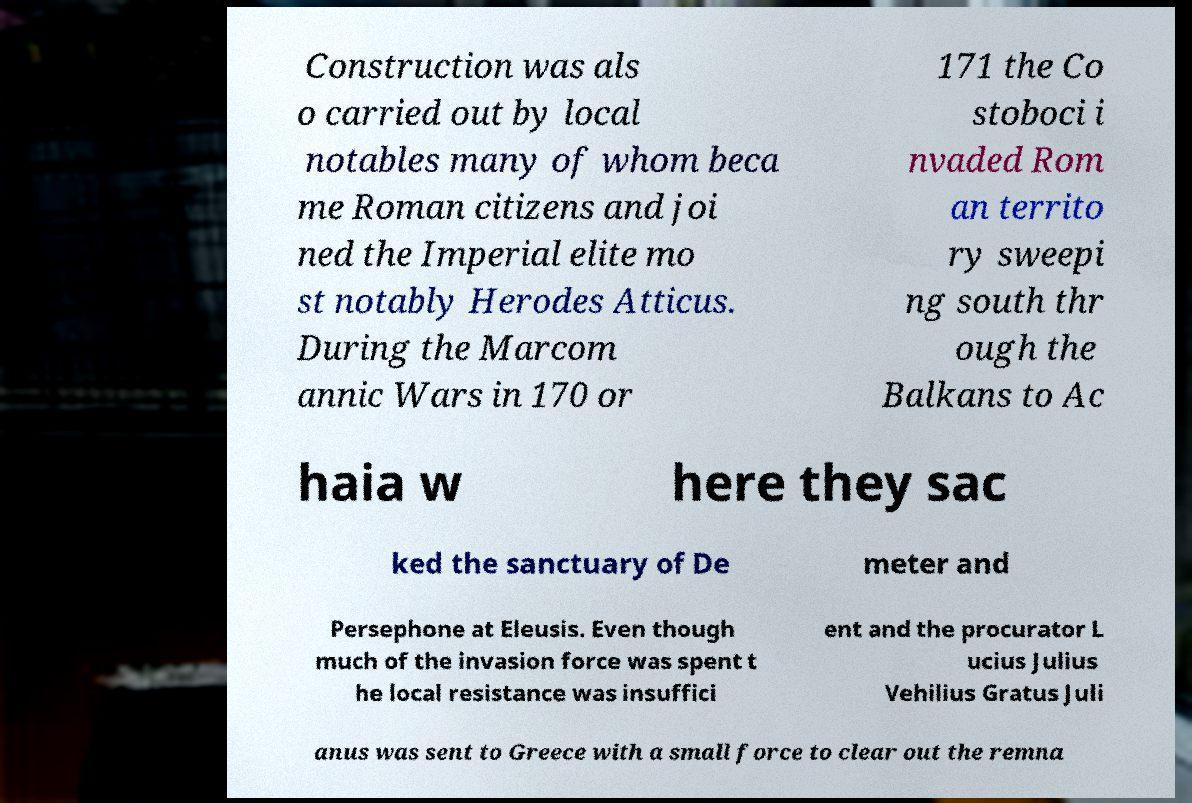Could you extract and type out the text from this image? Construction was als o carried out by local notables many of whom beca me Roman citizens and joi ned the Imperial elite mo st notably Herodes Atticus. During the Marcom annic Wars in 170 or 171 the Co stoboci i nvaded Rom an territo ry sweepi ng south thr ough the Balkans to Ac haia w here they sac ked the sanctuary of De meter and Persephone at Eleusis. Even though much of the invasion force was spent t he local resistance was insuffici ent and the procurator L ucius Julius Vehilius Gratus Juli anus was sent to Greece with a small force to clear out the remna 